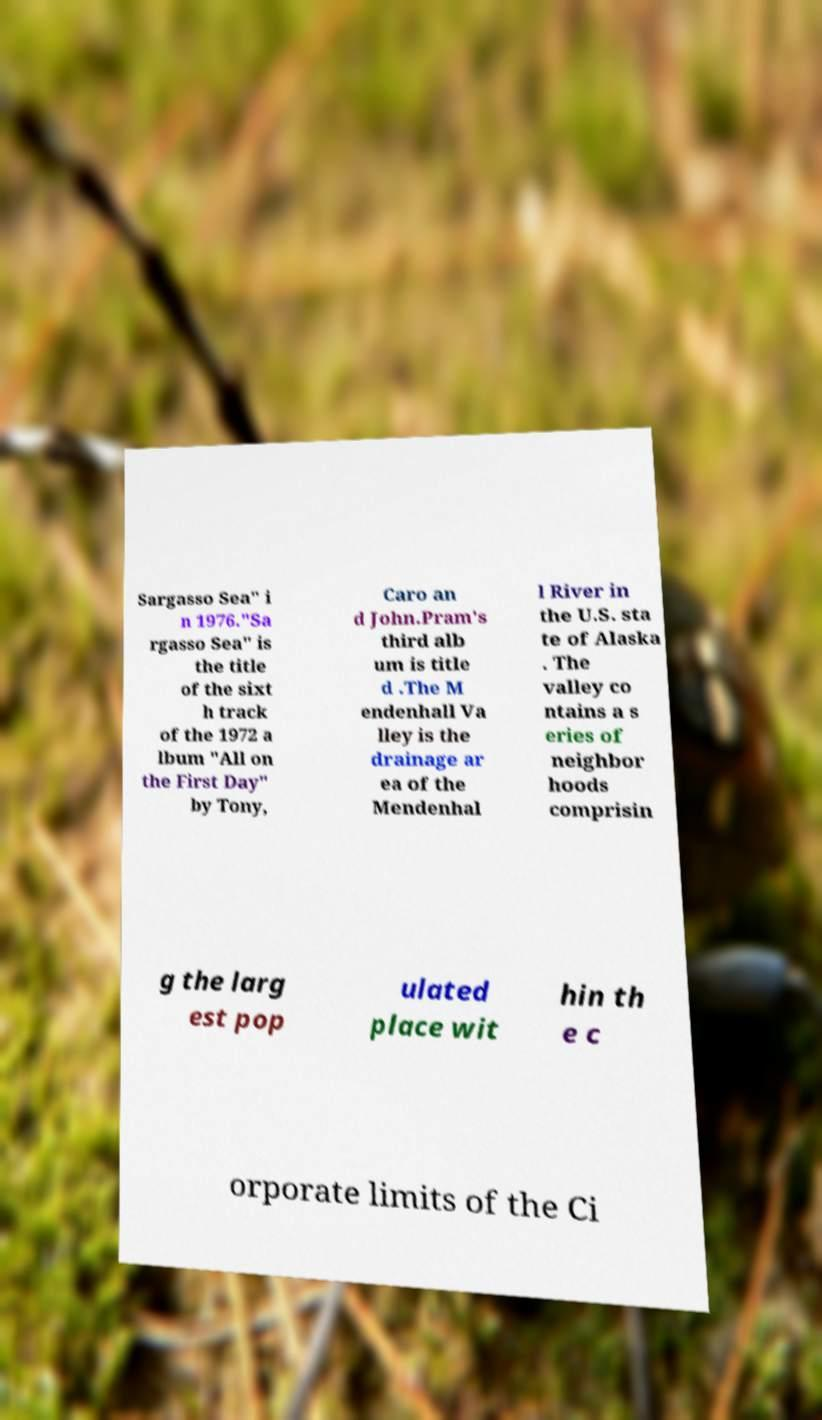Can you read and provide the text displayed in the image?This photo seems to have some interesting text. Can you extract and type it out for me? Sargasso Sea" i n 1976."Sa rgasso Sea" is the title of the sixt h track of the 1972 a lbum "All on the First Day" by Tony, Caro an d John.Pram's third alb um is title d .The M endenhall Va lley is the drainage ar ea of the Mendenhal l River in the U.S. sta te of Alaska . The valley co ntains a s eries of neighbor hoods comprisin g the larg est pop ulated place wit hin th e c orporate limits of the Ci 